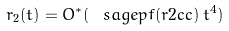Convert formula to latex. <formula><loc_0><loc_0><loc_500><loc_500>r _ { 2 } ( t ) = O ^ { * } ( \ s a g e { p f ( r 2 c c ) } \, t ^ { 4 } )</formula> 